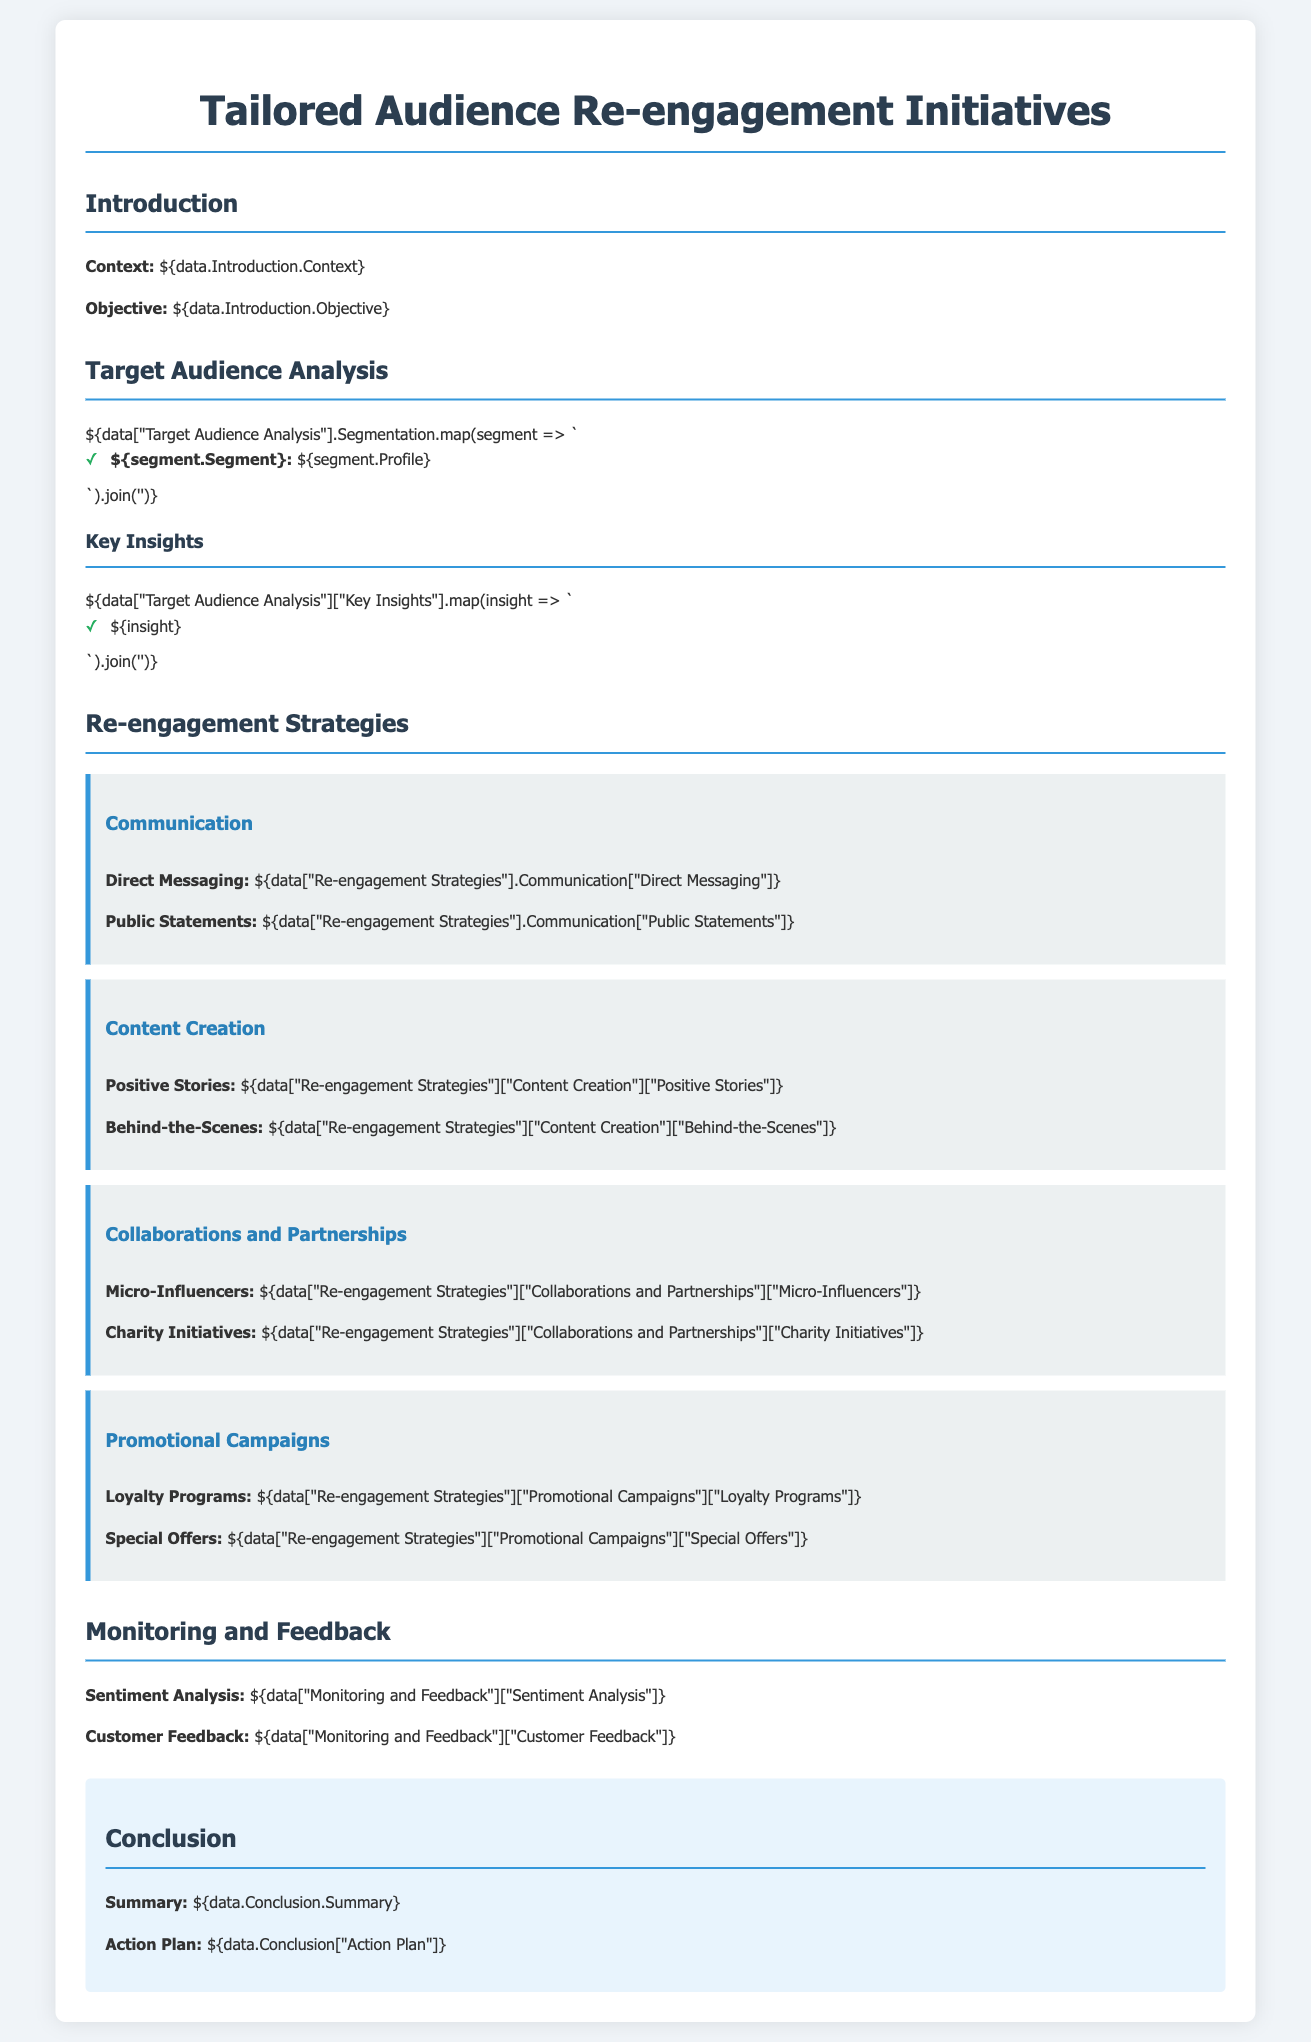What is the objective of the re-engagement initiatives? The objective is stated in the introduction section of the document.
Answer: Recovery from influencer backlash What are the two segments of the target audience? The segments are listed in the Target Audience Analysis section.
Answer: Segment A and Segment B What strategy is used for communication in re-engagement? The strategy includes methods listed under the Re-engagement Strategies section.
Answer: Direct Messaging and Public Statements What is one key insight from the target audience analysis? Key insights are provided in a list in the document.
Answer: Influencer trust levels are low How many re-engagement strategies are detailed in the document? The document describes multiple strategies under their respective sections.
Answer: Four What is one type of collaboration mentioned in the document? The collaborations are specified in the Re-engagement Strategies section.
Answer: Micro-Influencers What is emphasized in the positive stories of content creation? The document details specific aspects under the content creation strategy.
Answer: Positive brand experiences What feedback method is included in monitoring? Monitoring methods are outlined in the Monitoring and Feedback section.
Answer: Customer Feedback What is the summary of the conclusion? The summary is provided at the end of the document.
Answer: A need for strategic communication What is one action plan listed in the conclusion? The action plan can be found in the concluding section of the document.
Answer: Implement loyalty programs 